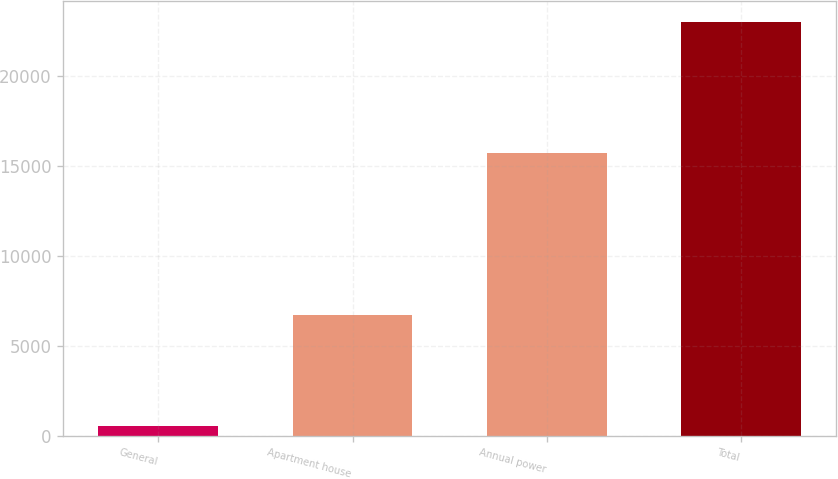<chart> <loc_0><loc_0><loc_500><loc_500><bar_chart><fcel>General<fcel>Apartment house<fcel>Annual power<fcel>Total<nl><fcel>544<fcel>6725<fcel>15748<fcel>23017<nl></chart> 